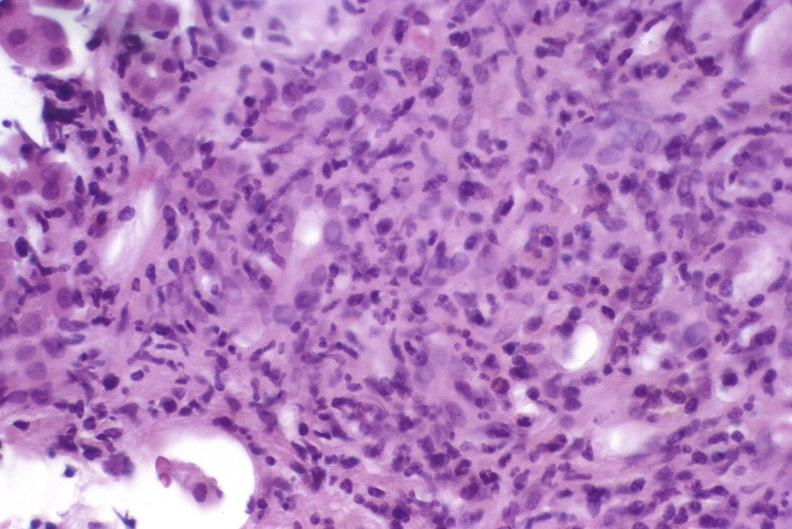what is present?
Answer the question using a single word or phrase. Hepatobiliary 